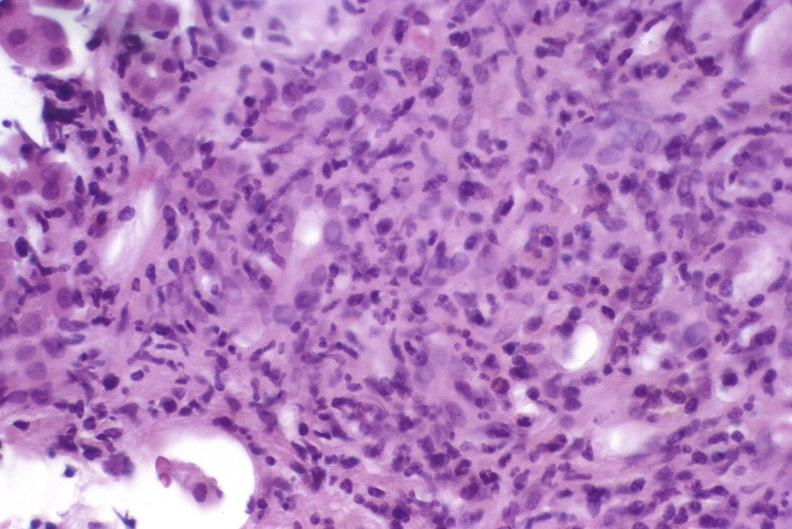what is present?
Answer the question using a single word or phrase. Hepatobiliary 